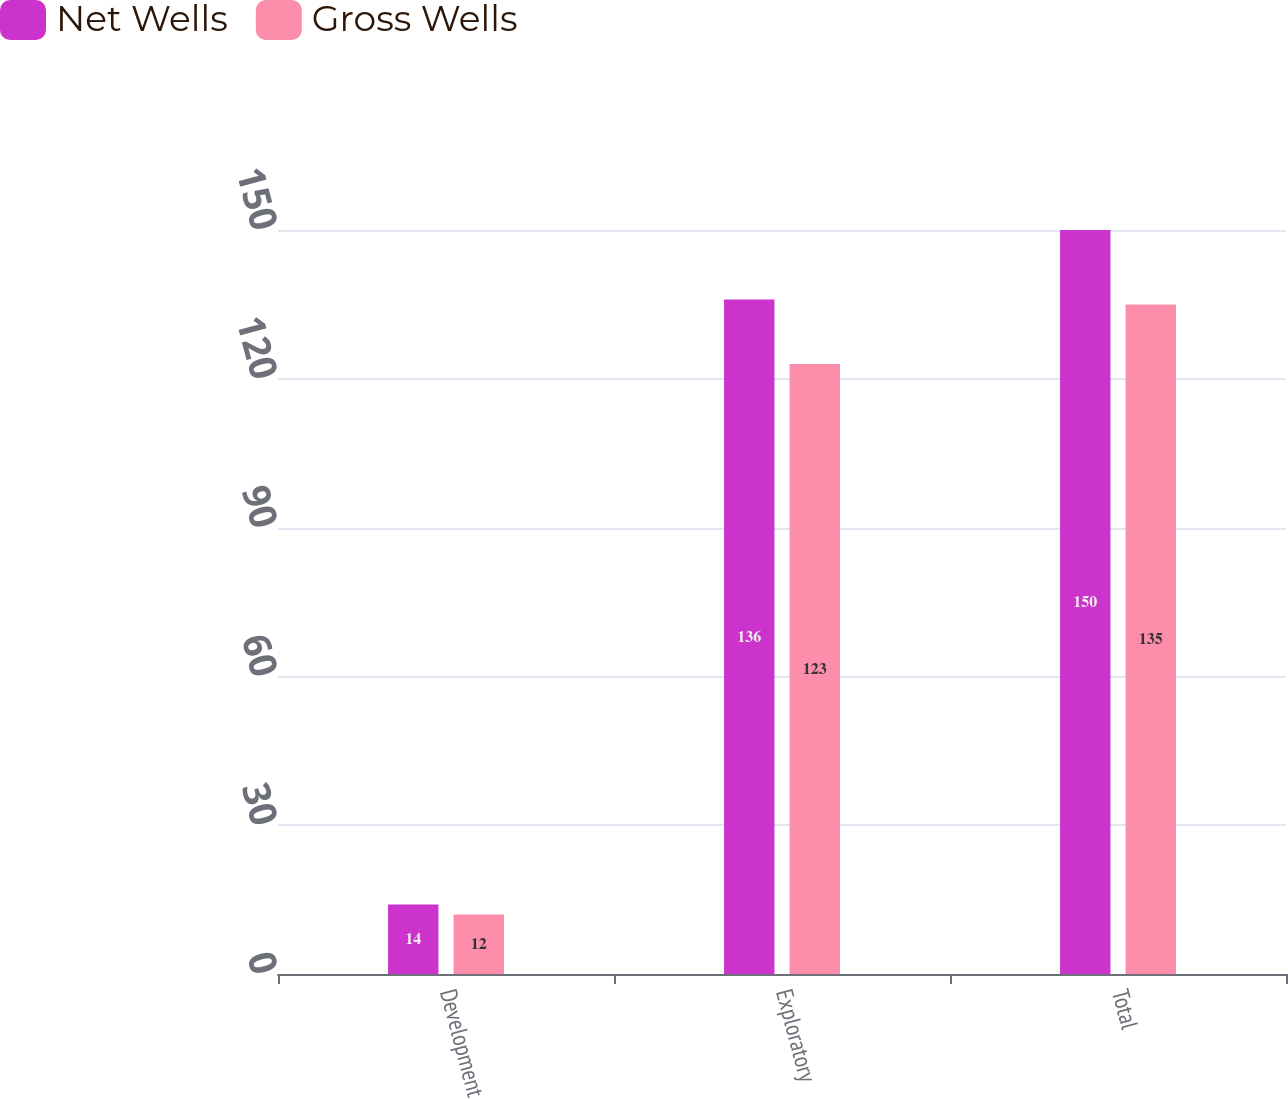Convert chart to OTSL. <chart><loc_0><loc_0><loc_500><loc_500><stacked_bar_chart><ecel><fcel>Development<fcel>Exploratory<fcel>Total<nl><fcel>Net Wells<fcel>14<fcel>136<fcel>150<nl><fcel>Gross Wells<fcel>12<fcel>123<fcel>135<nl></chart> 